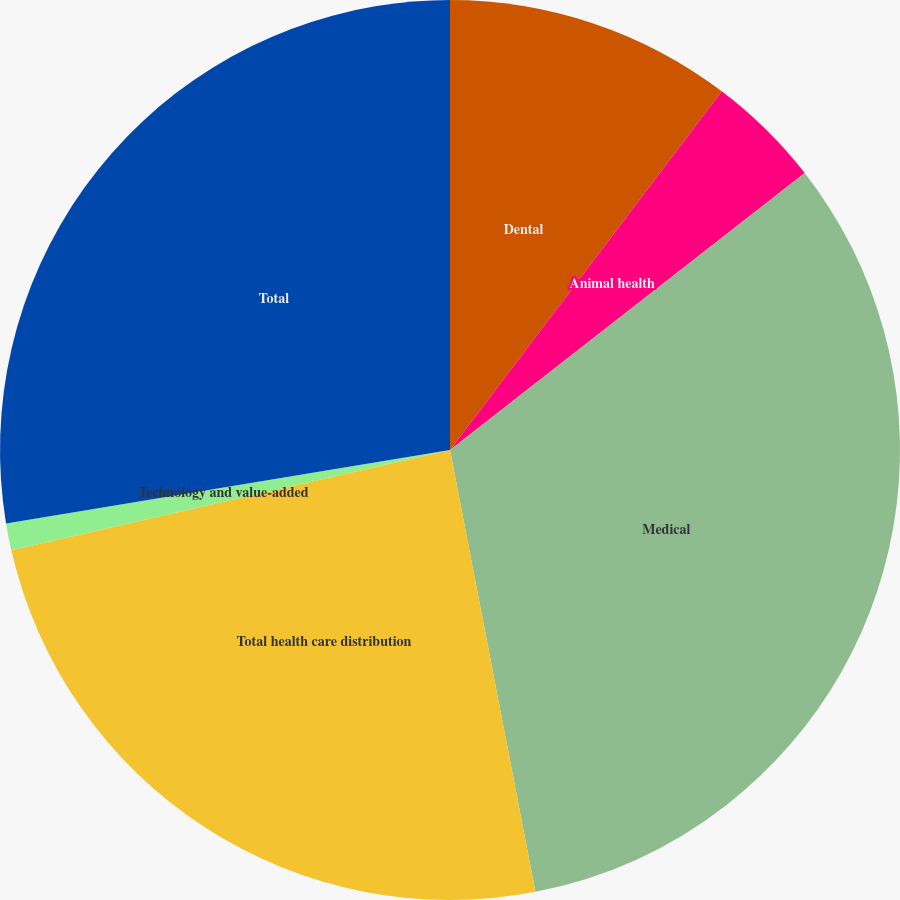Convert chart to OTSL. <chart><loc_0><loc_0><loc_500><loc_500><pie_chart><fcel>Dental<fcel>Animal health<fcel>Medical<fcel>Total health care distribution<fcel>Technology and value-added<fcel>Total<nl><fcel>10.32%<fcel>4.13%<fcel>32.51%<fcel>24.46%<fcel>0.97%<fcel>27.61%<nl></chart> 